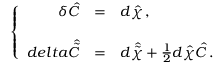<formula> <loc_0><loc_0><loc_500><loc_500>\left \{ \begin{array} { r c l } { { \delta \hat { C } } } & { = } & { { d \hat { \chi } \, , } } \\ { { d e l t a \hat { \tilde { C } } } } & { = } & { { d \hat { \tilde { \chi } } + \frac { 1 } { 2 } d \hat { \chi } \hat { C } \, . } } \end{array}</formula> 